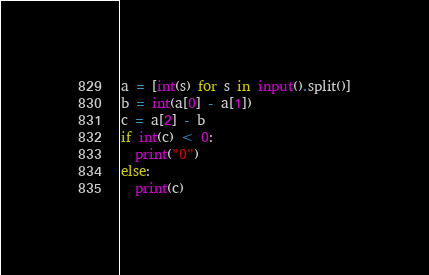<code> <loc_0><loc_0><loc_500><loc_500><_Python_>a = [int(s) for s in input().split()]
b = int(a[0] - a[1])
c = a[2] - b
if int(c) < 0:
  print("0")
else:
  print(c)</code> 